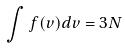<formula> <loc_0><loc_0><loc_500><loc_500>\int f ( v ) d v = 3 N</formula> 